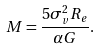<formula> <loc_0><loc_0><loc_500><loc_500>M = \frac { 5 \sigma _ { v } ^ { 2 } R _ { e } } { \alpha G } .</formula> 